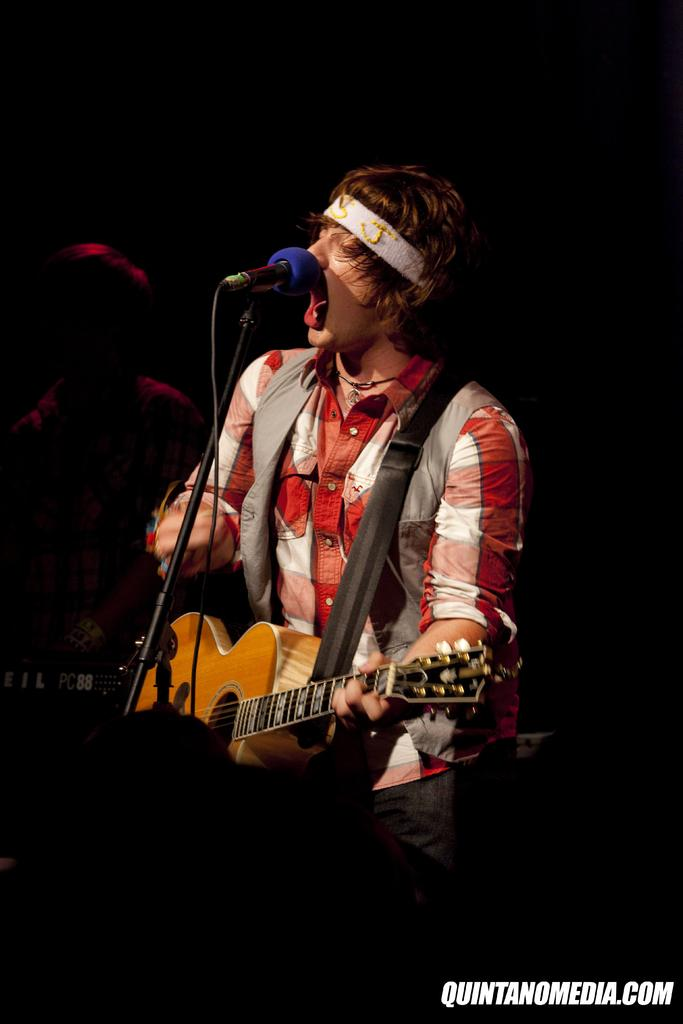What is the main subject of the image? The main subject of the image is a man. What is the man doing in the image? The man is singing on a mic and playing a guitar. Can you describe the background of the image? The background of the image is dark. How many trails can be seen behind the man in the image? There are no trails visible in the image. What type of hydrant is present in the image? There is no hydrant present in the image. 